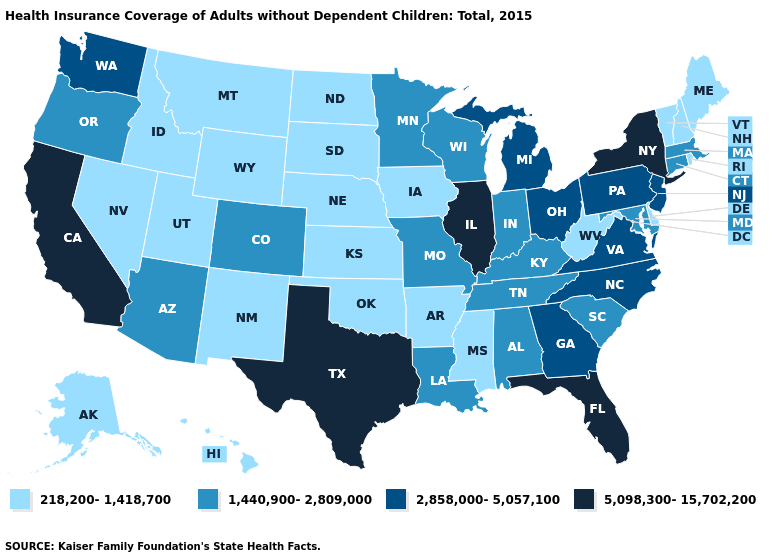Which states have the lowest value in the USA?
Be succinct. Alaska, Arkansas, Delaware, Hawaii, Idaho, Iowa, Kansas, Maine, Mississippi, Montana, Nebraska, Nevada, New Hampshire, New Mexico, North Dakota, Oklahoma, Rhode Island, South Dakota, Utah, Vermont, West Virginia, Wyoming. Name the states that have a value in the range 1,440,900-2,809,000?
Concise answer only. Alabama, Arizona, Colorado, Connecticut, Indiana, Kentucky, Louisiana, Maryland, Massachusetts, Minnesota, Missouri, Oregon, South Carolina, Tennessee, Wisconsin. Name the states that have a value in the range 1,440,900-2,809,000?
Be succinct. Alabama, Arizona, Colorado, Connecticut, Indiana, Kentucky, Louisiana, Maryland, Massachusetts, Minnesota, Missouri, Oregon, South Carolina, Tennessee, Wisconsin. Name the states that have a value in the range 5,098,300-15,702,200?
Concise answer only. California, Florida, Illinois, New York, Texas. What is the value of Montana?
Answer briefly. 218,200-1,418,700. Which states have the lowest value in the West?
Concise answer only. Alaska, Hawaii, Idaho, Montana, Nevada, New Mexico, Utah, Wyoming. What is the lowest value in the South?
Write a very short answer. 218,200-1,418,700. What is the lowest value in the USA?
Give a very brief answer. 218,200-1,418,700. What is the lowest value in the USA?
Short answer required. 218,200-1,418,700. Does Texas have the highest value in the South?
Be succinct. Yes. Name the states that have a value in the range 5,098,300-15,702,200?
Write a very short answer. California, Florida, Illinois, New York, Texas. Among the states that border Mississippi , which have the lowest value?
Short answer required. Arkansas. Name the states that have a value in the range 1,440,900-2,809,000?
Short answer required. Alabama, Arizona, Colorado, Connecticut, Indiana, Kentucky, Louisiana, Maryland, Massachusetts, Minnesota, Missouri, Oregon, South Carolina, Tennessee, Wisconsin. What is the value of Utah?
Short answer required. 218,200-1,418,700. Does the first symbol in the legend represent the smallest category?
Write a very short answer. Yes. 